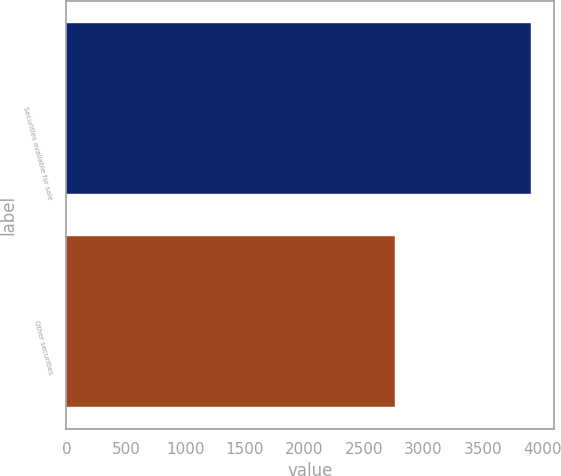Convert chart to OTSL. <chart><loc_0><loc_0><loc_500><loc_500><bar_chart><fcel>Securities available for sale<fcel>Other securities<nl><fcel>3907<fcel>2766<nl></chart> 